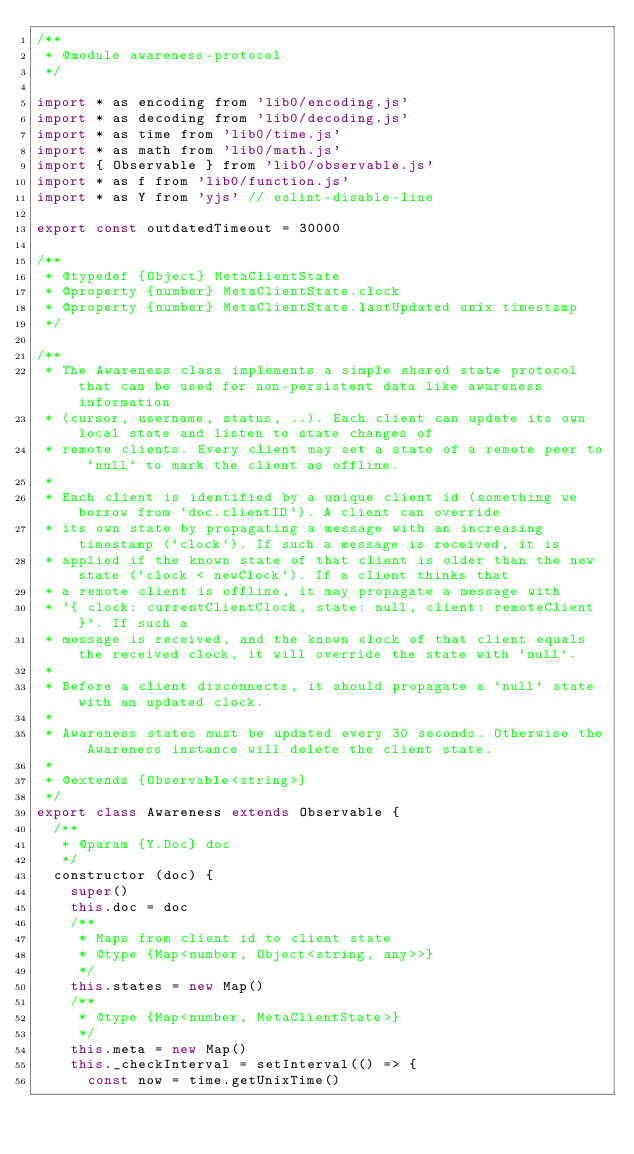Convert code to text. <code><loc_0><loc_0><loc_500><loc_500><_JavaScript_>/**
 * @module awareness-protocol
 */

import * as encoding from 'lib0/encoding.js'
import * as decoding from 'lib0/decoding.js'
import * as time from 'lib0/time.js'
import * as math from 'lib0/math.js'
import { Observable } from 'lib0/observable.js'
import * as f from 'lib0/function.js'
import * as Y from 'yjs' // eslint-disable-line

export const outdatedTimeout = 30000

/**
 * @typedef {Object} MetaClientState
 * @property {number} MetaClientState.clock
 * @property {number} MetaClientState.lastUpdated unix timestamp
 */

/**
 * The Awareness class implements a simple shared state protocol that can be used for non-persistent data like awareness information
 * (cursor, username, status, ..). Each client can update its own local state and listen to state changes of
 * remote clients. Every client may set a state of a remote peer to `null` to mark the client as offline.
 *
 * Each client is identified by a unique client id (something we borrow from `doc.clientID`). A client can override
 * its own state by propagating a message with an increasing timestamp (`clock`). If such a message is received, it is
 * applied if the known state of that client is older than the new state (`clock < newClock`). If a client thinks that
 * a remote client is offline, it may propagate a message with
 * `{ clock: currentClientClock, state: null, client: remoteClient }`. If such a
 * message is received, and the known clock of that client equals the received clock, it will override the state with `null`.
 *
 * Before a client disconnects, it should propagate a `null` state with an updated clock.
 *
 * Awareness states must be updated every 30 seconds. Otherwise the Awareness instance will delete the client state.
 *
 * @extends {Observable<string>}
 */
export class Awareness extends Observable {
  /**
   * @param {Y.Doc} doc
   */
  constructor (doc) {
    super()
    this.doc = doc
    /**
     * Maps from client id to client state
     * @type {Map<number, Object<string, any>>}
     */
    this.states = new Map()
    /**
     * @type {Map<number, MetaClientState>}
     */
    this.meta = new Map()
    this._checkInterval = setInterval(() => {
      const now = time.getUnixTime()</code> 